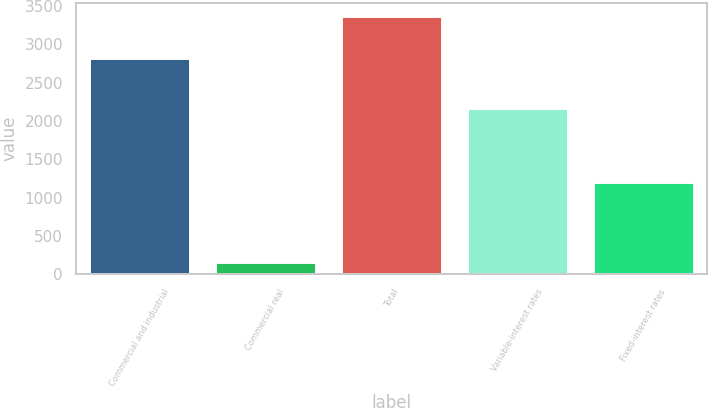<chart> <loc_0><loc_0><loc_500><loc_500><bar_chart><fcel>Commercial and industrial<fcel>Commercial real<fcel>Total<fcel>Variable-interest rates<fcel>Fixed-interest rates<nl><fcel>2826<fcel>162<fcel>3368<fcel>2166<fcel>1202<nl></chart> 